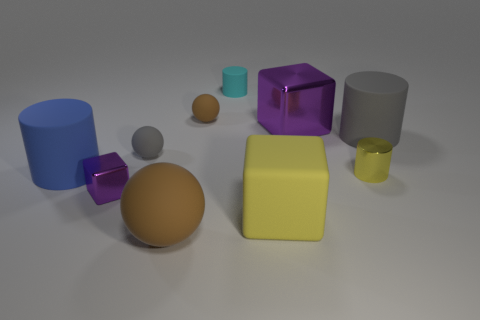Subtract all purple spheres. Subtract all brown cylinders. How many spheres are left? 3 Subtract all spheres. How many objects are left? 7 Subtract all cyan shiny cubes. Subtract all large blue rubber cylinders. How many objects are left? 9 Add 8 small metal blocks. How many small metal blocks are left? 9 Add 9 small yellow objects. How many small yellow objects exist? 10 Subtract 0 red cubes. How many objects are left? 10 